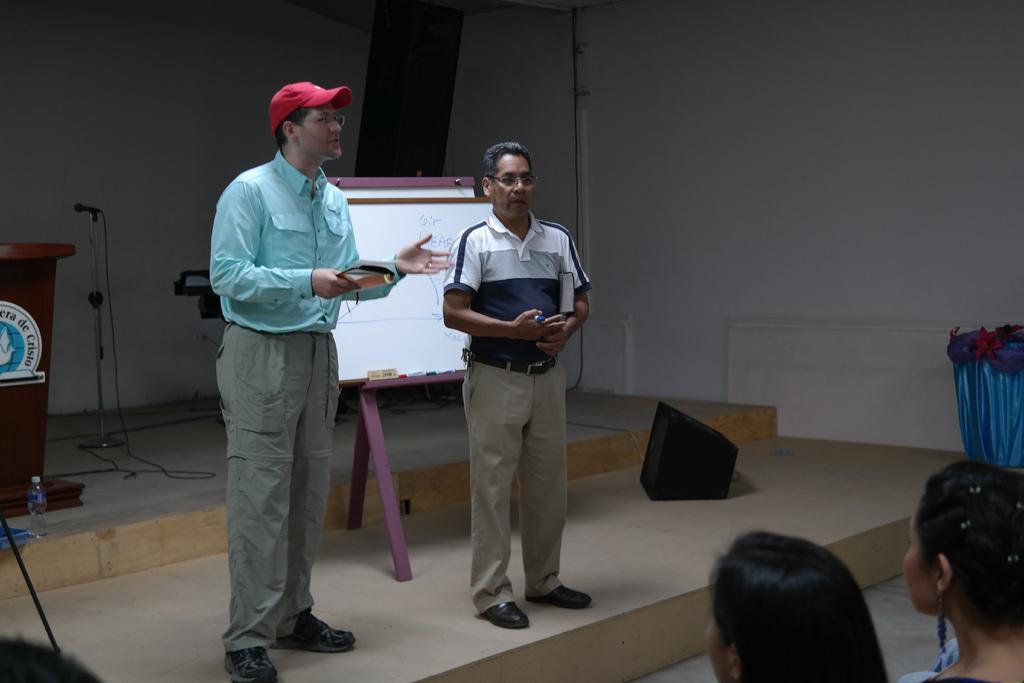In one or two sentences, can you explain what this image depicts? In this image there are two persons ,and at the background there is a speaker, board on the stand, duster, markers, two persons standing and holding some objects, water bottle, mike with a stand , wall, podium. 